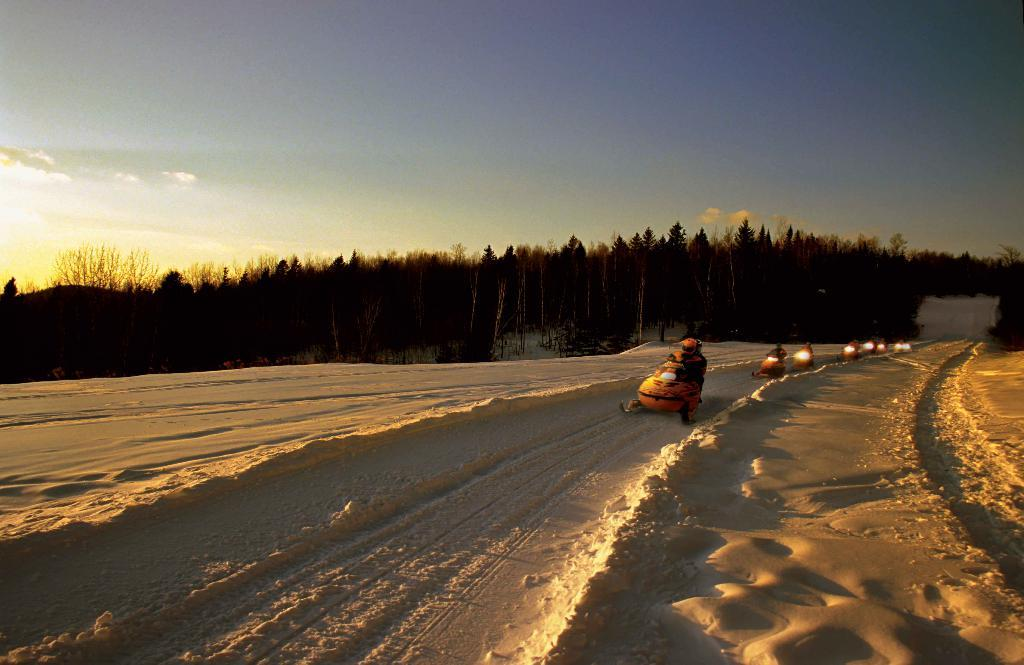What is happening on the snow in the image? There are vehicles on the snow in the image. Who is inside the vehicles? There are people in the cars. What can be seen in the background of the image? There are trees and the sky visible in the background of the image. Are there any brushes visible in the image? No, there are no brushes present in the image. How many horses can be seen in the image? There are no horses visible in the image. 